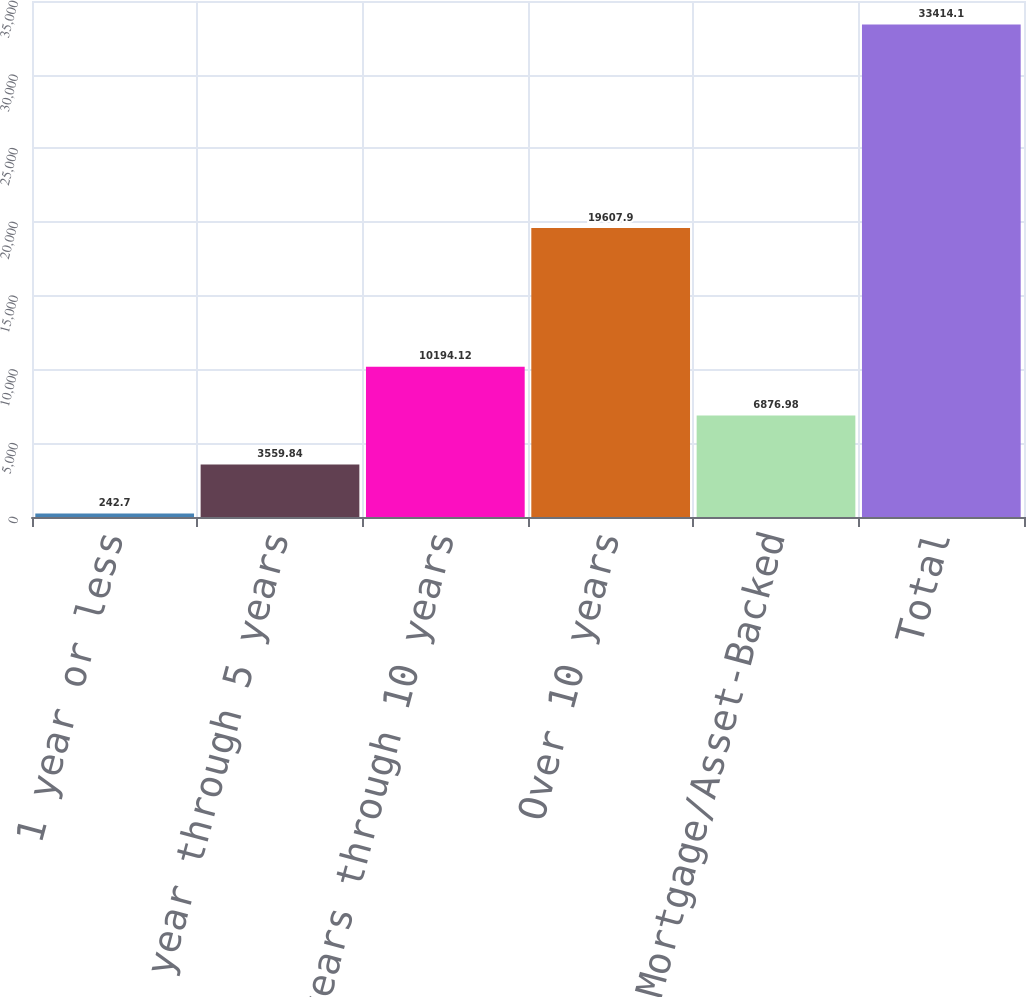Convert chart. <chart><loc_0><loc_0><loc_500><loc_500><bar_chart><fcel>1 year or less<fcel>Over 1 year through 5 years<fcel>Over 5 years through 10 years<fcel>Over 10 years<fcel>Mortgage/Asset-Backed<fcel>Total<nl><fcel>242.7<fcel>3559.84<fcel>10194.1<fcel>19607.9<fcel>6876.98<fcel>33414.1<nl></chart> 